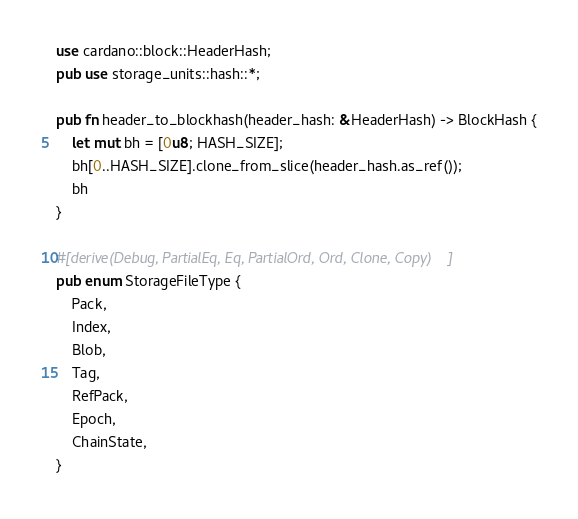<code> <loc_0><loc_0><loc_500><loc_500><_Rust_>use cardano::block::HeaderHash;
pub use storage_units::hash::*;

pub fn header_to_blockhash(header_hash: &HeaderHash) -> BlockHash {
    let mut bh = [0u8; HASH_SIZE];
    bh[0..HASH_SIZE].clone_from_slice(header_hash.as_ref());
    bh
}

#[derive(Debug, PartialEq, Eq, PartialOrd, Ord, Clone, Copy)]
pub enum StorageFileType {
    Pack,
    Index,
    Blob,
    Tag,
    RefPack,
    Epoch,
    ChainState,
}
</code> 